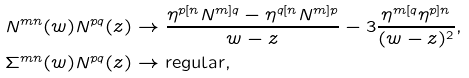Convert formula to latex. <formula><loc_0><loc_0><loc_500><loc_500>N ^ { m n } ( w ) N ^ { p q } ( z ) & \rightarrow \frac { \eta ^ { p [ n } N ^ { m ] q } - \eta ^ { q [ n } N ^ { m ] p } } { w - z } - 3 \frac { \eta ^ { m [ q } \eta ^ { p ] n } } { ( w - z ) ^ { 2 } } , \\ \Sigma ^ { m n } ( w ) N ^ { p q } ( z ) & \rightarrow \text {regular} ,</formula> 